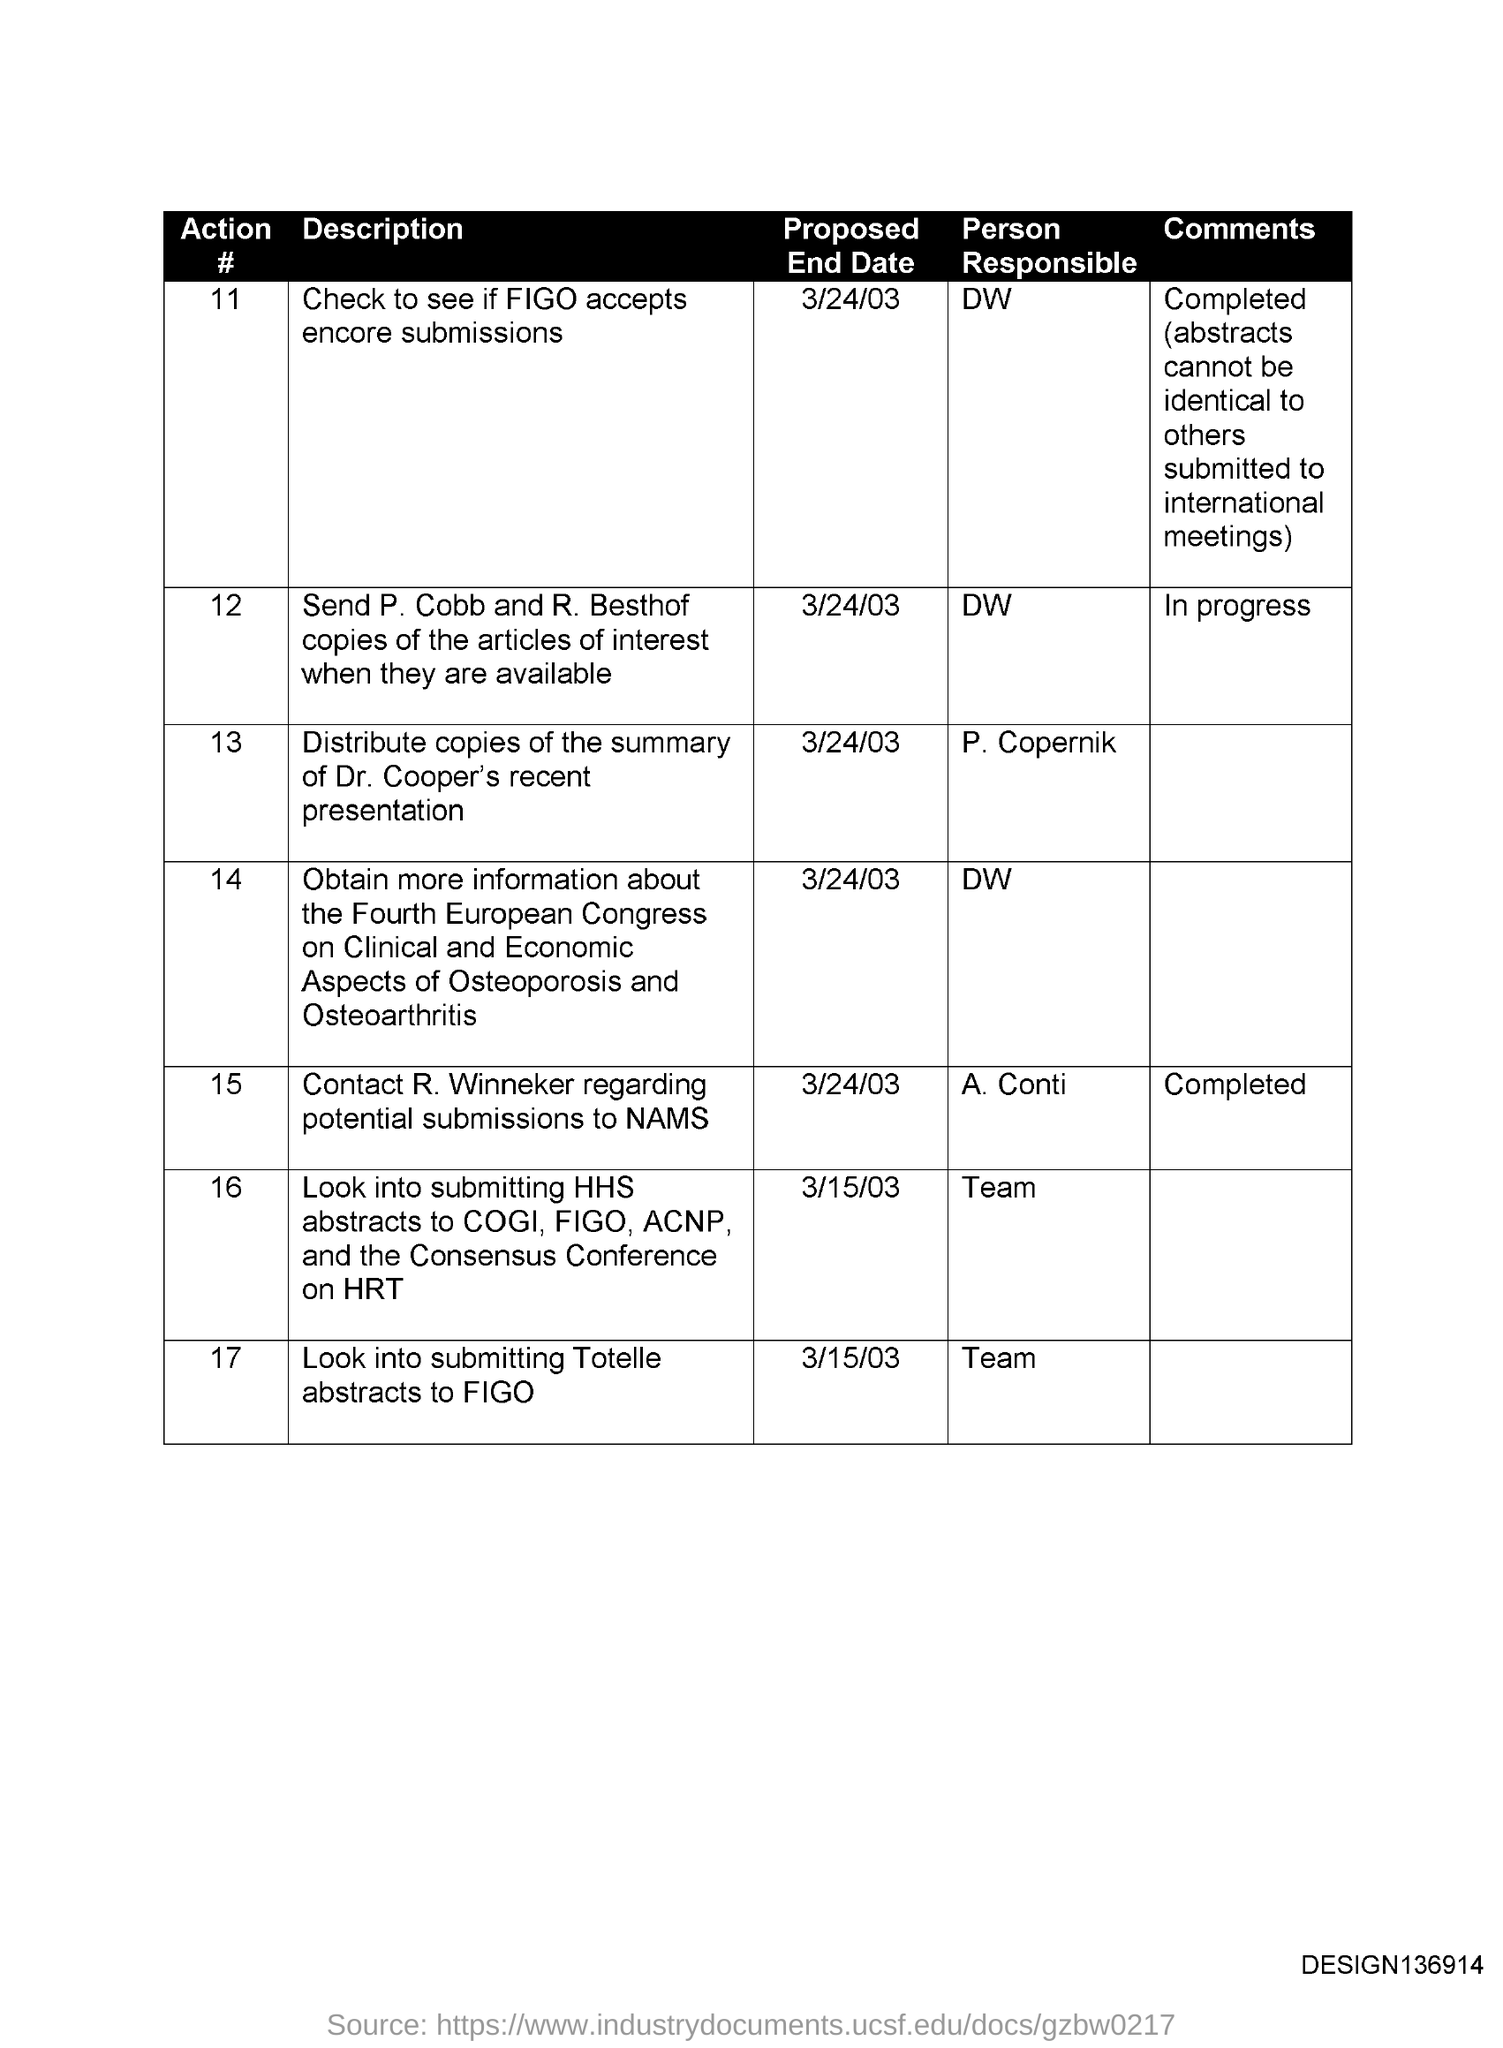Highlight a few significant elements in this photo. The person responsible for action #11 is DW. The code on the bottom right corner is "DESIGN136914. The heading for the second column is 'DESCRIPTION.' The proposed end date for Action #11 is March 24, 2003. The comments for Action #12 are about the progress of the action. 